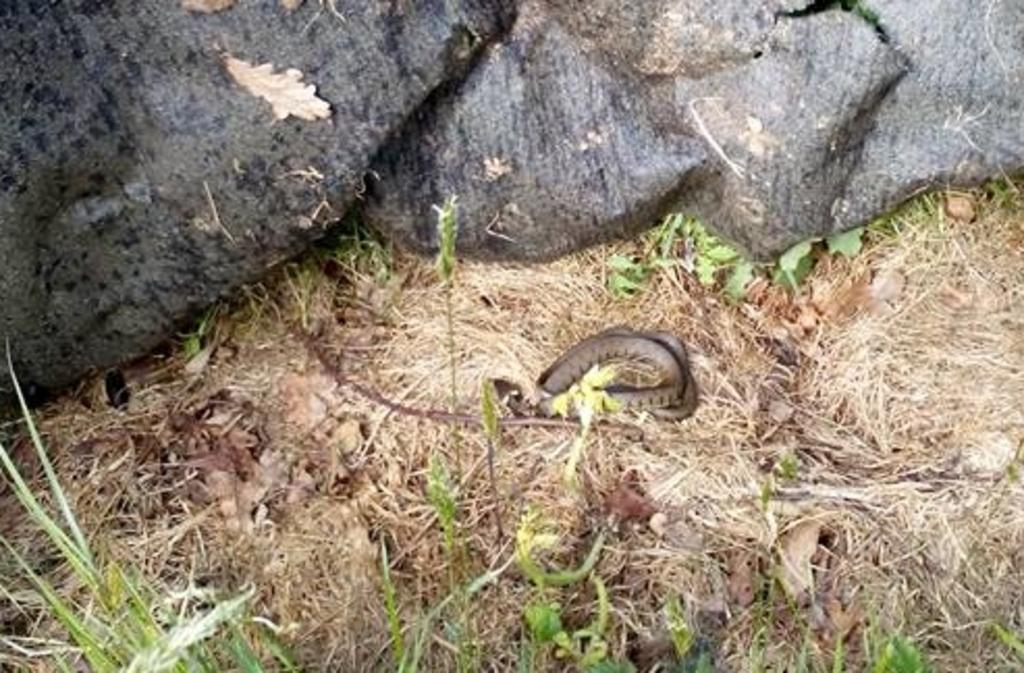What animal is present in the image? There is a snake in the image. Where is the snake located? The snake is on a grass path. What can be seen in front of the snake? There are plants in front of the snake. What is behind the snake? There is a rock behind the snake. How many horses are visible in the image? There are no horses present in the image; it features a snake on a grass path with plants and a rock. What type of trick does the snake perform in the image? There is no trick being performed by the snake in the image; it is simply resting on the grass path. 